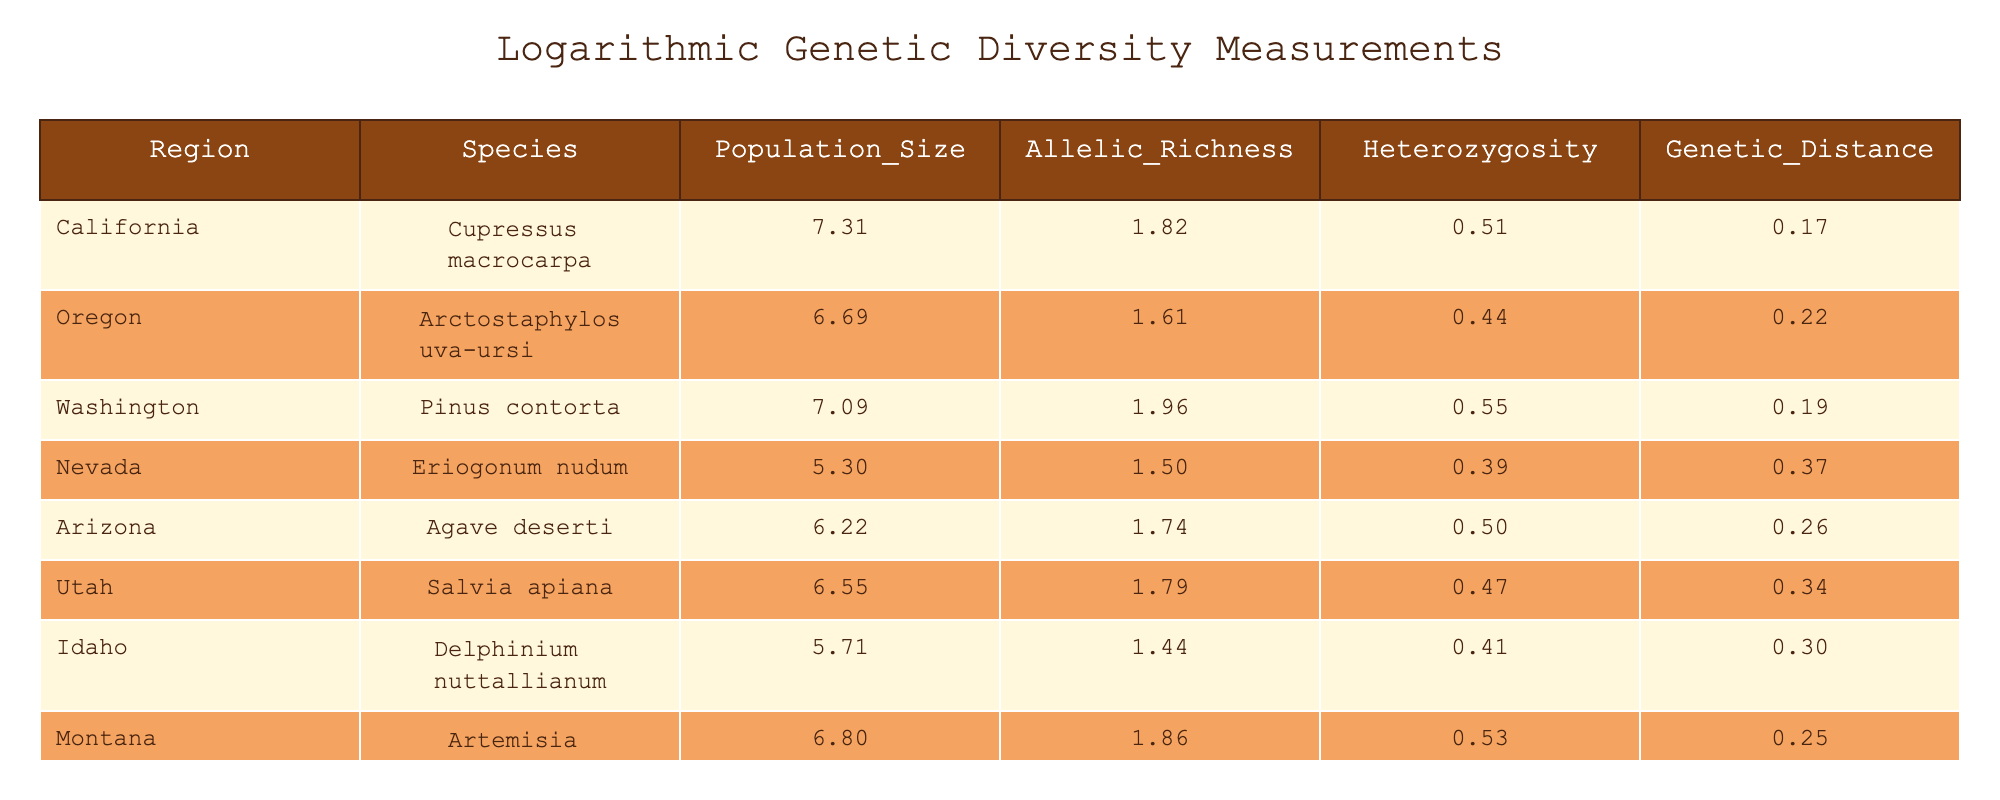What is the allelic richness of Agave deserti? The table shows that the 'Allelic_Richness' column lists the value for Agave deserti under the 'Arizona' region. Referring to the table, the value is 4.7.
Answer: 4.7 Which species has the highest heterozygosity? By scanning the 'Heterozygosity' column in the table, we look for the maximum value. The highest value listed is 0.73, which corresponds to Pinus contorta from Washington.
Answer: Pinus contorta Is the average population size of species from the California and Arizona regions greater than 1000? To find the average, we first determine the population sizes for California (1500) and Arizona (500), giving us a total of 2000. We then divide by 2, which equals 1000. Since 1000 is not greater, the answer is no.
Answer: No What is the genetic distance of the species with the lowest allelic richness? The species with the lowest allelic richness is Eriogonum nudum, with an allelic richness of 3.5, and its genetic distance listed in the table is 0.45.
Answer: 0.45 Calculate the difference in genetic distance between Eriogonum nudum and Delphinium nuttallianum. Eriogonum nudum has a genetic distance of 0.45, and Delphinium nuttallianum has a genetic distance of 0.35. The difference can be calculated by subtracting the values: 0.45 - 0.35 = 0.10.
Answer: 0.10 Which region has a species with the second lowest heterozygosity and what is the value? To find this, we look at the 'Heterozygosity' column and identify the values: 0.48, 0.50, 0.56, etc. The second lowest value is 0.50, which corresponds to Delphinium nuttallianum from Idaho.
Answer: Idaho, 0.50 What is the combined allelic richness for the species from California and Oregon? The allelic richness for California (5.2) and Oregon (4.0) adds up to 9.2. This is done by simply summing both values: 5.2 + 4.0 = 9.2.
Answer: 9.2 Is the heterozygosity of Salvia apiana greater than or equal to 0.60? Referring to the table, Salvia apiana has a heterozygosity value of 0.60. Since it is equal to 0.60, the answer is yes.
Answer: Yes 